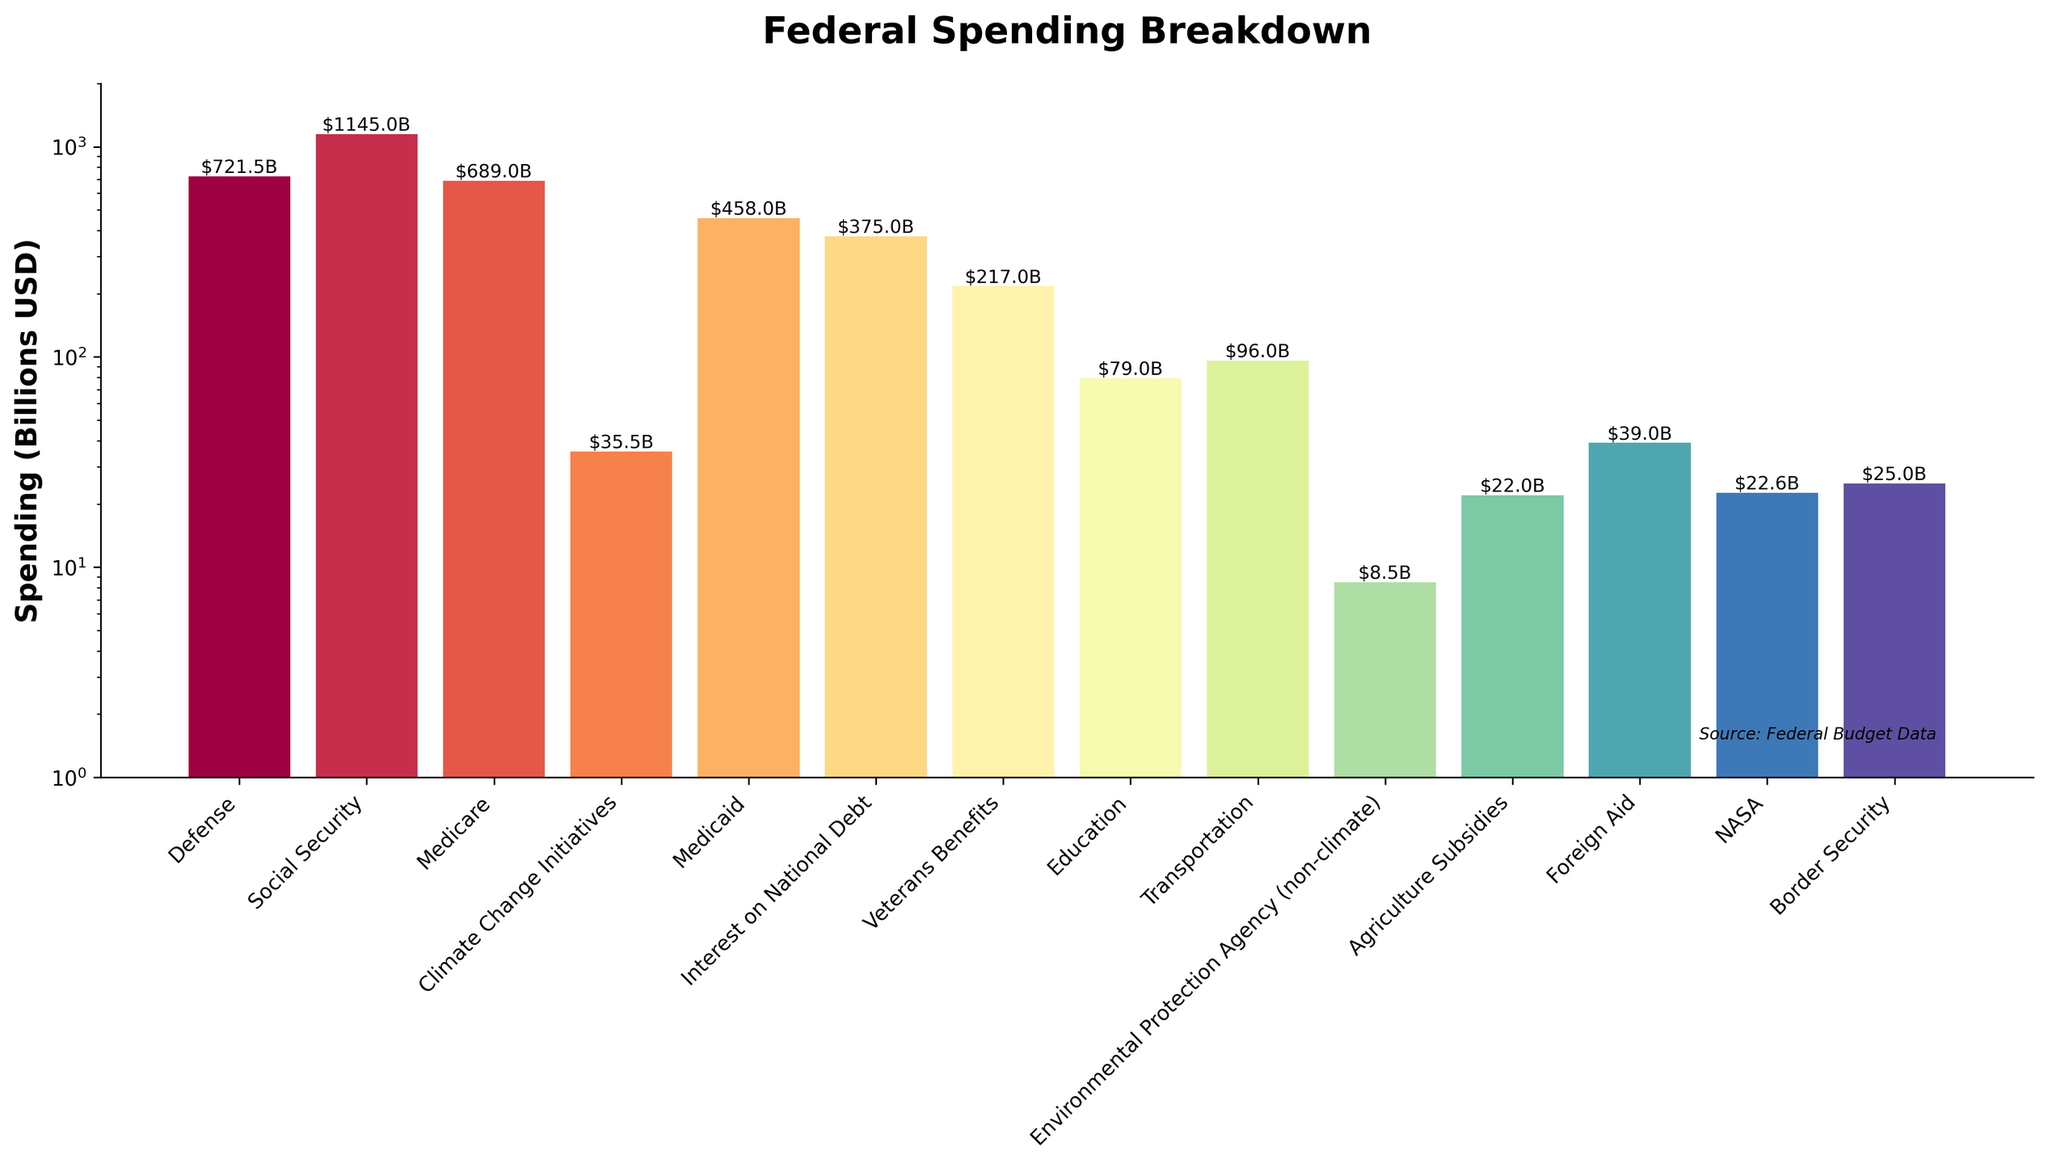Which category has the highest spending? By observing the height of the bars, we can see that the Social Security bar is the tallest, indicating the highest spending.
Answer: Social Security What is the difference in spending between Medicare and Medicaid? The height of the Medicare bar is $689.0B and the height of the Medicaid bar is $458.0B. Subtracting Medicaid's spending from Medicare's gives $689.0B - $458.0B.
Answer: $231.0B How does the spending on climate change initiatives compare to interest on the national debt? The Climate Change Initiatives spending bar is significantly shorter than the Interest on National Debt bar. The exact values are $35.5B for Climate Change Initiatives and $375.0B for Interest on National Debt.
Answer: Climate Change Initiatives spending is much lower Which categories have lower spending than climate change initiatives? By comparing the heights of the bars visually, the categories with lower spending than Climate Change Initiatives ($35.5B) are Environmental Protection Agency (non-climate) and Agriculture Subsidies.
Answer: Environmental Protection Agency (non-climate), Agriculture Subsidies Calculate the total spending of Defense, Social Security, and Medicare? Add the heights of the bars corresponding to these categories: Defense ($721.5B), Social Security ($1145.0B), and Medicare ($689.0B). The total is $721.5B + $1145.0B + $689.0B.
Answer: $2555.5B What is the average spending on Foreign Aid, NASA, and Border Security? Sum the spending of Foreign Aid ($39.0B), NASA ($22.6B), and Border Security ($25.0B) and divide by 3. The sum is $39.0B + $22.6B + $25.0B = $86.6B. The average is $86.6B / 3.
Answer: $28.87B Which category has almost the same spending as Border Security? The bar visually closest in height to the Border Security ($25.0B) bar is Agriculture Subsidies ($22.0B).
Answer: Agriculture Subsidies How many categories have spending over $500 billion? By counting the number of bars exceeding the $500B mark on the y-axis, we find Defense, Social Security, and Medicare.
Answer: Three What is the spending ratio between Defense and Education? To find the ratio, divide Defense spending ($721.5B) by Education spending ($79.0B); thus, $721.5B / $79.0B.
Answer: Approximately 9.1 Is the spending on Veterans Benefits higher or lower than on Transportation? Compare the heights of the respective bars: Veterans Benefits ($217.0B) is higher than Transportation ($96.0B).
Answer: Higher 